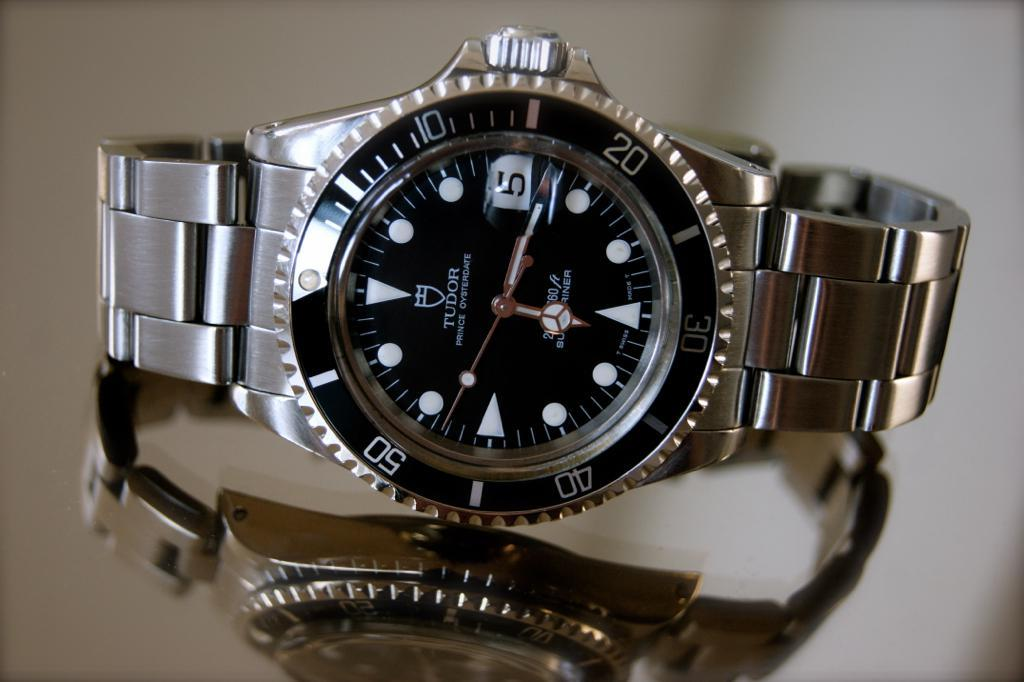<image>
Render a clear and concise summary of the photo. a clock that has the number 5 on it 